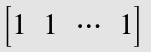<formula> <loc_0><loc_0><loc_500><loc_500>\begin{bmatrix} 1 & 1 & \cdots & 1 \\ \end{bmatrix}</formula> 